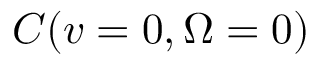Convert formula to latex. <formula><loc_0><loc_0><loc_500><loc_500>C ( v = 0 , { \Omega } = 0 )</formula> 